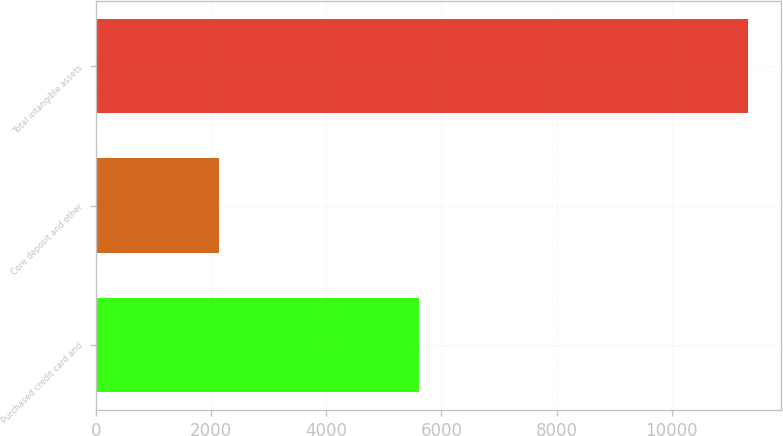Convert chart. <chart><loc_0><loc_0><loc_500><loc_500><bar_chart><fcel>Purchased credit card and<fcel>Core deposit and other<fcel>Total intangible assets<nl><fcel>5604<fcel>2140<fcel>11328<nl></chart> 